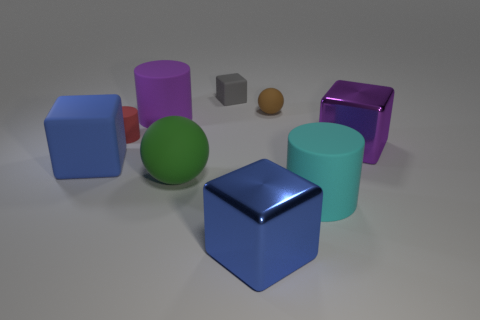Which object stands out the most due to its color or texture? The large, shiny, magenta-colored cylinder stands out prominently due to its vibrant color and reflective surface, contrasting with the more subdued hues and matte finishes of some surrounding objects. 